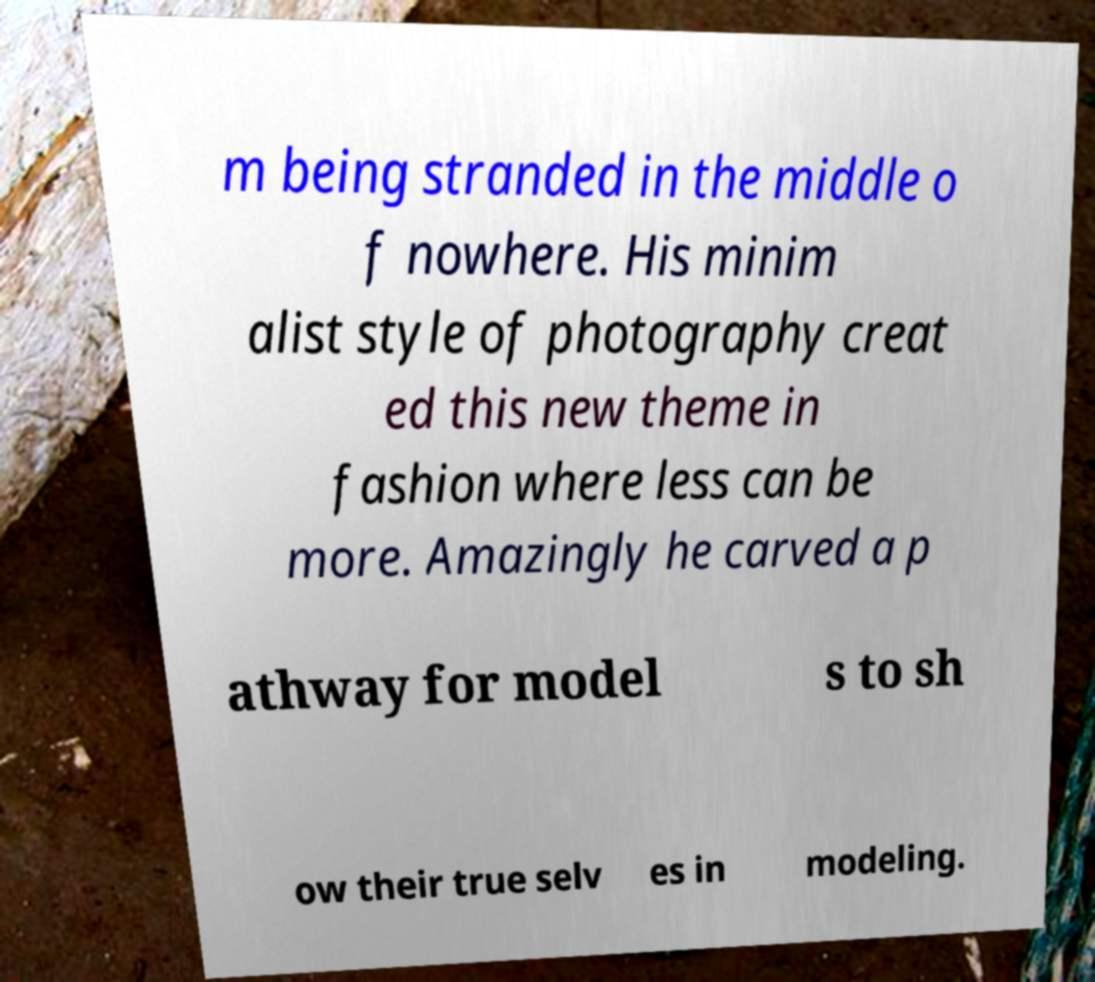Could you extract and type out the text from this image? m being stranded in the middle o f nowhere. His minim alist style of photography creat ed this new theme in fashion where less can be more. Amazingly he carved a p athway for model s to sh ow their true selv es in modeling. 